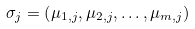Convert formula to latex. <formula><loc_0><loc_0><loc_500><loc_500>\sigma _ { j } = \left ( { \mu _ { 1 , j } , \mu _ { 2 , j } , \dots , \mu _ { m , j } } \right )</formula> 